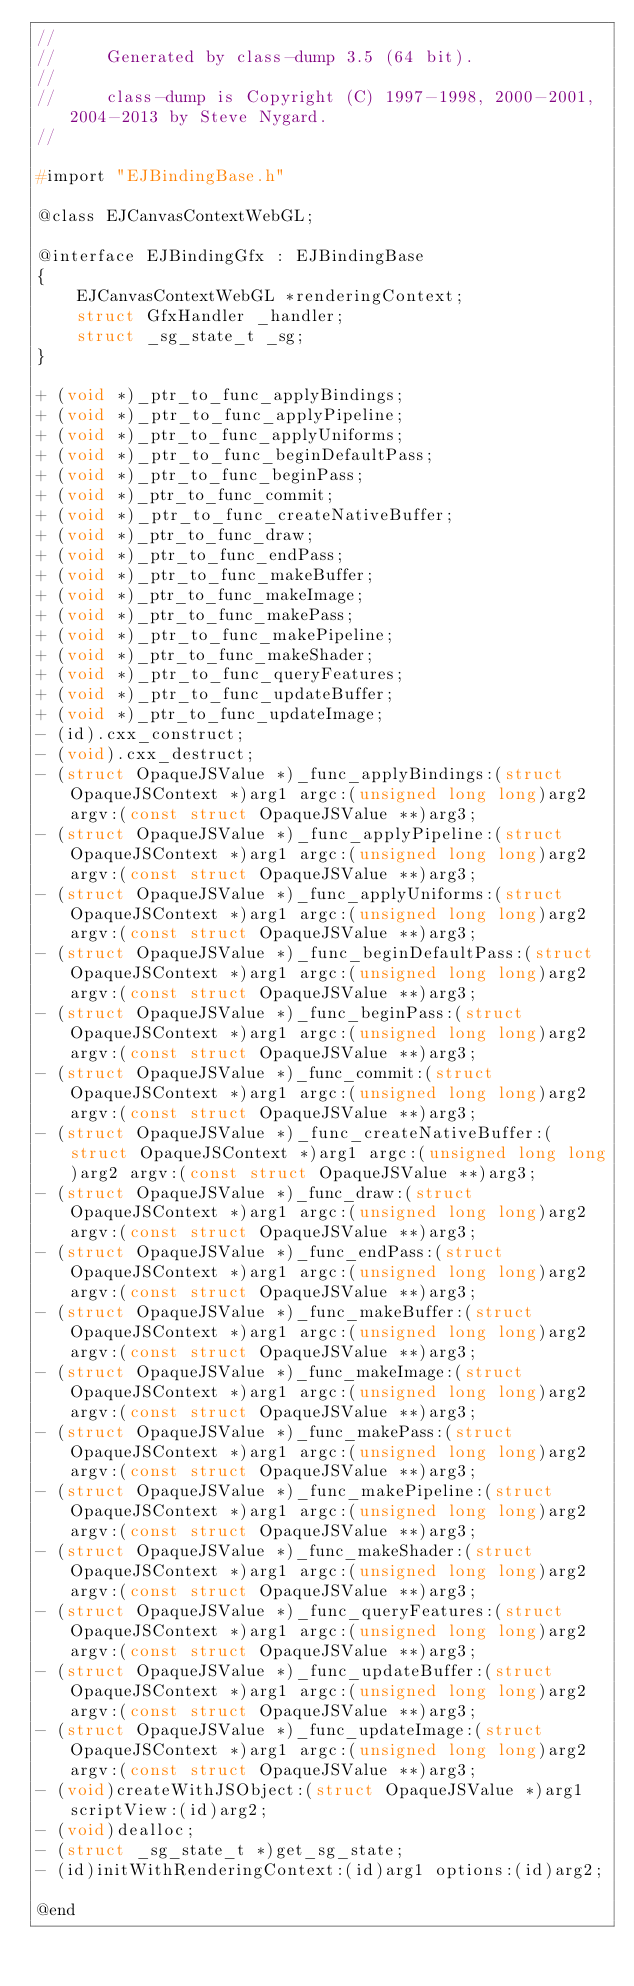Convert code to text. <code><loc_0><loc_0><loc_500><loc_500><_C_>//
//     Generated by class-dump 3.5 (64 bit).
//
//     class-dump is Copyright (C) 1997-1998, 2000-2001, 2004-2013 by Steve Nygard.
//

#import "EJBindingBase.h"

@class EJCanvasContextWebGL;

@interface EJBindingGfx : EJBindingBase
{
    EJCanvasContextWebGL *renderingContext;
    struct GfxHandler _handler;
    struct _sg_state_t _sg;
}

+ (void *)_ptr_to_func_applyBindings;
+ (void *)_ptr_to_func_applyPipeline;
+ (void *)_ptr_to_func_applyUniforms;
+ (void *)_ptr_to_func_beginDefaultPass;
+ (void *)_ptr_to_func_beginPass;
+ (void *)_ptr_to_func_commit;
+ (void *)_ptr_to_func_createNativeBuffer;
+ (void *)_ptr_to_func_draw;
+ (void *)_ptr_to_func_endPass;
+ (void *)_ptr_to_func_makeBuffer;
+ (void *)_ptr_to_func_makeImage;
+ (void *)_ptr_to_func_makePass;
+ (void *)_ptr_to_func_makePipeline;
+ (void *)_ptr_to_func_makeShader;
+ (void *)_ptr_to_func_queryFeatures;
+ (void *)_ptr_to_func_updateBuffer;
+ (void *)_ptr_to_func_updateImage;
- (id).cxx_construct;
- (void).cxx_destruct;
- (struct OpaqueJSValue *)_func_applyBindings:(struct OpaqueJSContext *)arg1 argc:(unsigned long long)arg2 argv:(const struct OpaqueJSValue **)arg3;
- (struct OpaqueJSValue *)_func_applyPipeline:(struct OpaqueJSContext *)arg1 argc:(unsigned long long)arg2 argv:(const struct OpaqueJSValue **)arg3;
- (struct OpaqueJSValue *)_func_applyUniforms:(struct OpaqueJSContext *)arg1 argc:(unsigned long long)arg2 argv:(const struct OpaqueJSValue **)arg3;
- (struct OpaqueJSValue *)_func_beginDefaultPass:(struct OpaqueJSContext *)arg1 argc:(unsigned long long)arg2 argv:(const struct OpaqueJSValue **)arg3;
- (struct OpaqueJSValue *)_func_beginPass:(struct OpaqueJSContext *)arg1 argc:(unsigned long long)arg2 argv:(const struct OpaqueJSValue **)arg3;
- (struct OpaqueJSValue *)_func_commit:(struct OpaqueJSContext *)arg1 argc:(unsigned long long)arg2 argv:(const struct OpaqueJSValue **)arg3;
- (struct OpaqueJSValue *)_func_createNativeBuffer:(struct OpaqueJSContext *)arg1 argc:(unsigned long long)arg2 argv:(const struct OpaqueJSValue **)arg3;
- (struct OpaqueJSValue *)_func_draw:(struct OpaqueJSContext *)arg1 argc:(unsigned long long)arg2 argv:(const struct OpaqueJSValue **)arg3;
- (struct OpaqueJSValue *)_func_endPass:(struct OpaqueJSContext *)arg1 argc:(unsigned long long)arg2 argv:(const struct OpaqueJSValue **)arg3;
- (struct OpaqueJSValue *)_func_makeBuffer:(struct OpaqueJSContext *)arg1 argc:(unsigned long long)arg2 argv:(const struct OpaqueJSValue **)arg3;
- (struct OpaqueJSValue *)_func_makeImage:(struct OpaqueJSContext *)arg1 argc:(unsigned long long)arg2 argv:(const struct OpaqueJSValue **)arg3;
- (struct OpaqueJSValue *)_func_makePass:(struct OpaqueJSContext *)arg1 argc:(unsigned long long)arg2 argv:(const struct OpaqueJSValue **)arg3;
- (struct OpaqueJSValue *)_func_makePipeline:(struct OpaqueJSContext *)arg1 argc:(unsigned long long)arg2 argv:(const struct OpaqueJSValue **)arg3;
- (struct OpaqueJSValue *)_func_makeShader:(struct OpaqueJSContext *)arg1 argc:(unsigned long long)arg2 argv:(const struct OpaqueJSValue **)arg3;
- (struct OpaqueJSValue *)_func_queryFeatures:(struct OpaqueJSContext *)arg1 argc:(unsigned long long)arg2 argv:(const struct OpaqueJSValue **)arg3;
- (struct OpaqueJSValue *)_func_updateBuffer:(struct OpaqueJSContext *)arg1 argc:(unsigned long long)arg2 argv:(const struct OpaqueJSValue **)arg3;
- (struct OpaqueJSValue *)_func_updateImage:(struct OpaqueJSContext *)arg1 argc:(unsigned long long)arg2 argv:(const struct OpaqueJSValue **)arg3;
- (void)createWithJSObject:(struct OpaqueJSValue *)arg1 scriptView:(id)arg2;
- (void)dealloc;
- (struct _sg_state_t *)get_sg_state;
- (id)initWithRenderingContext:(id)arg1 options:(id)arg2;

@end

</code> 